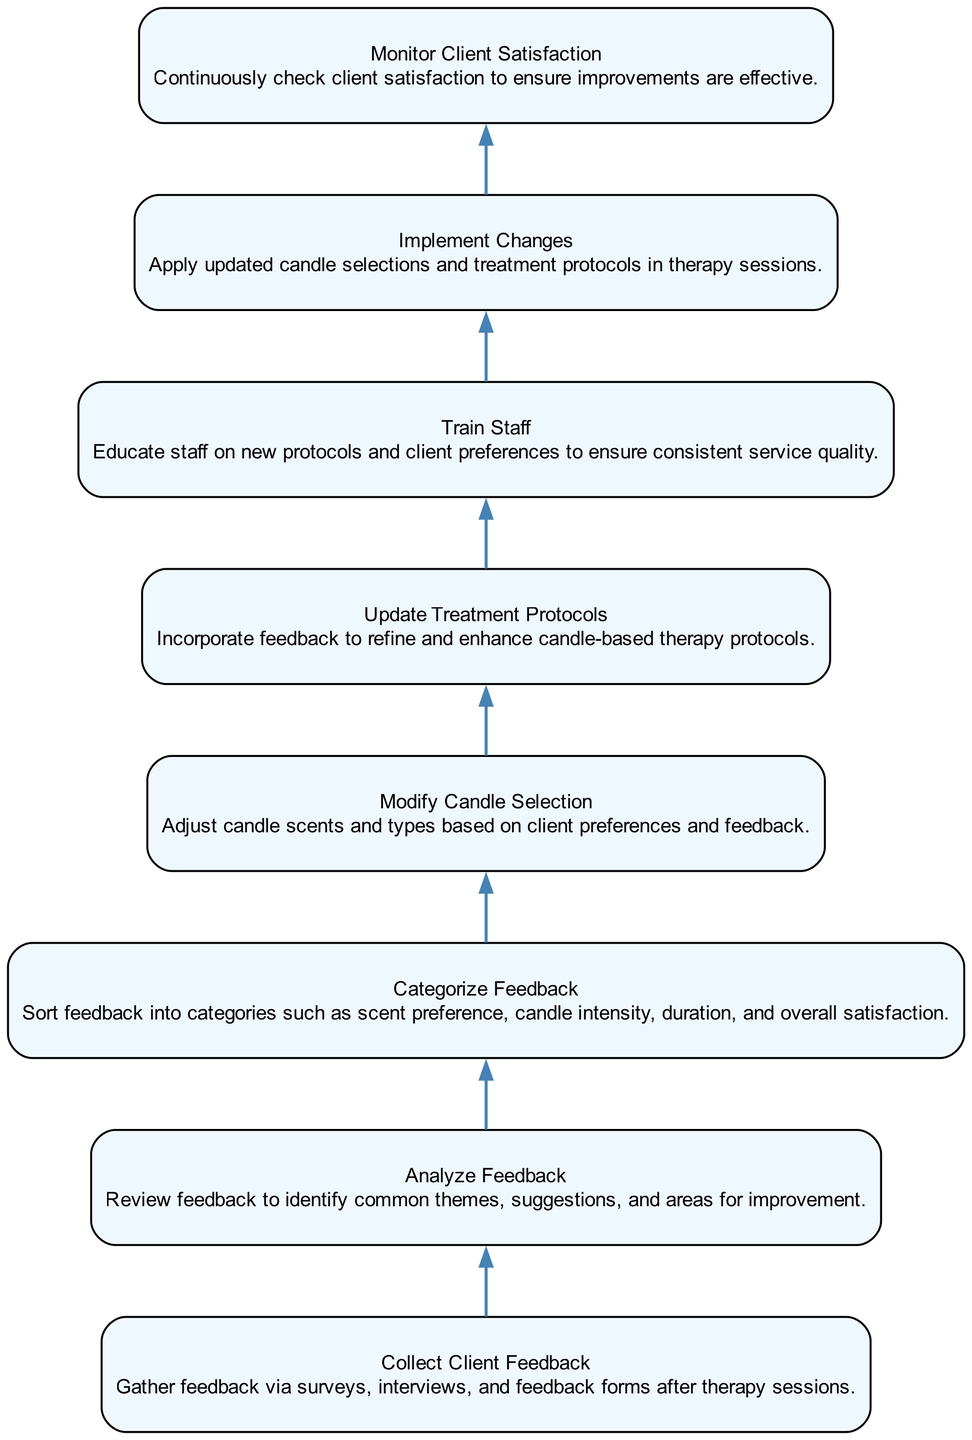What is the first action in the flowchart? The first action is indicated by the bottom node of the flowchart, which is "Collect Client Feedback". This node is positioned at the base of the flow, signifying that it initiates the process.
Answer: Collect Client Feedback What does the "Train Staff" action involve? The "Train Staff" action is described as educating staff on new protocols and client preferences. This can be found in the node referred to as "Train Staff", which specifies the focus of training in relation to feedback incorporation.
Answer: Educate staff on new protocols and client preferences How many nodes are present in the flowchart? By counting each unique action represented in the flowchart, a total of eight distinct nodes can be observed, each associated with specific actions in the feedback integration process.
Answer: Eight Which action comes immediately before "Implement Changes"? The action that precedes "Implement Changes" is "Train Staff", indicating that staff training is a necessary step before the changes are put into practice in the therapy sessions.
Answer: Train Staff What is the last action in the flowchart? The last action, indicated at the top of the flowchart, is "Monitor Client Satisfaction". This signifies the concluding step of the process where ongoing client satisfaction is assessed.
Answer: Monitor Client Satisfaction What actions are involved after "Analyze Feedback"? Following "Analyze Feedback", the next action is "Categorize Feedback", and then "Modify Candle Selection" follows. This sequence indicates that after feedback analysis, it is essential to categorize the input before making modifications based on that categorization.
Answer: Categorize Feedback, Modify Candle Selection What is the relationship between "Update Treatment Protocols" and "Modify Candle Selection"? "Update Treatment Protocols" follows "Modify Candle Selection" in the sequence of actions, meaning that once the candle selection is modified, the next step is to integrate those changes into the treatment protocols. The relationship is sequential, where the outcome of one directly influences the next.
Answer: Sequential relationship What action comes directly before "Monitor Client Satisfaction"? The action preceding "Monitor Client Satisfaction" is "Implement Changes", indicating that monitoring client satisfaction occurs after the updates and modifications have been applied to the therapy sessions.
Answer: Implement Changes 